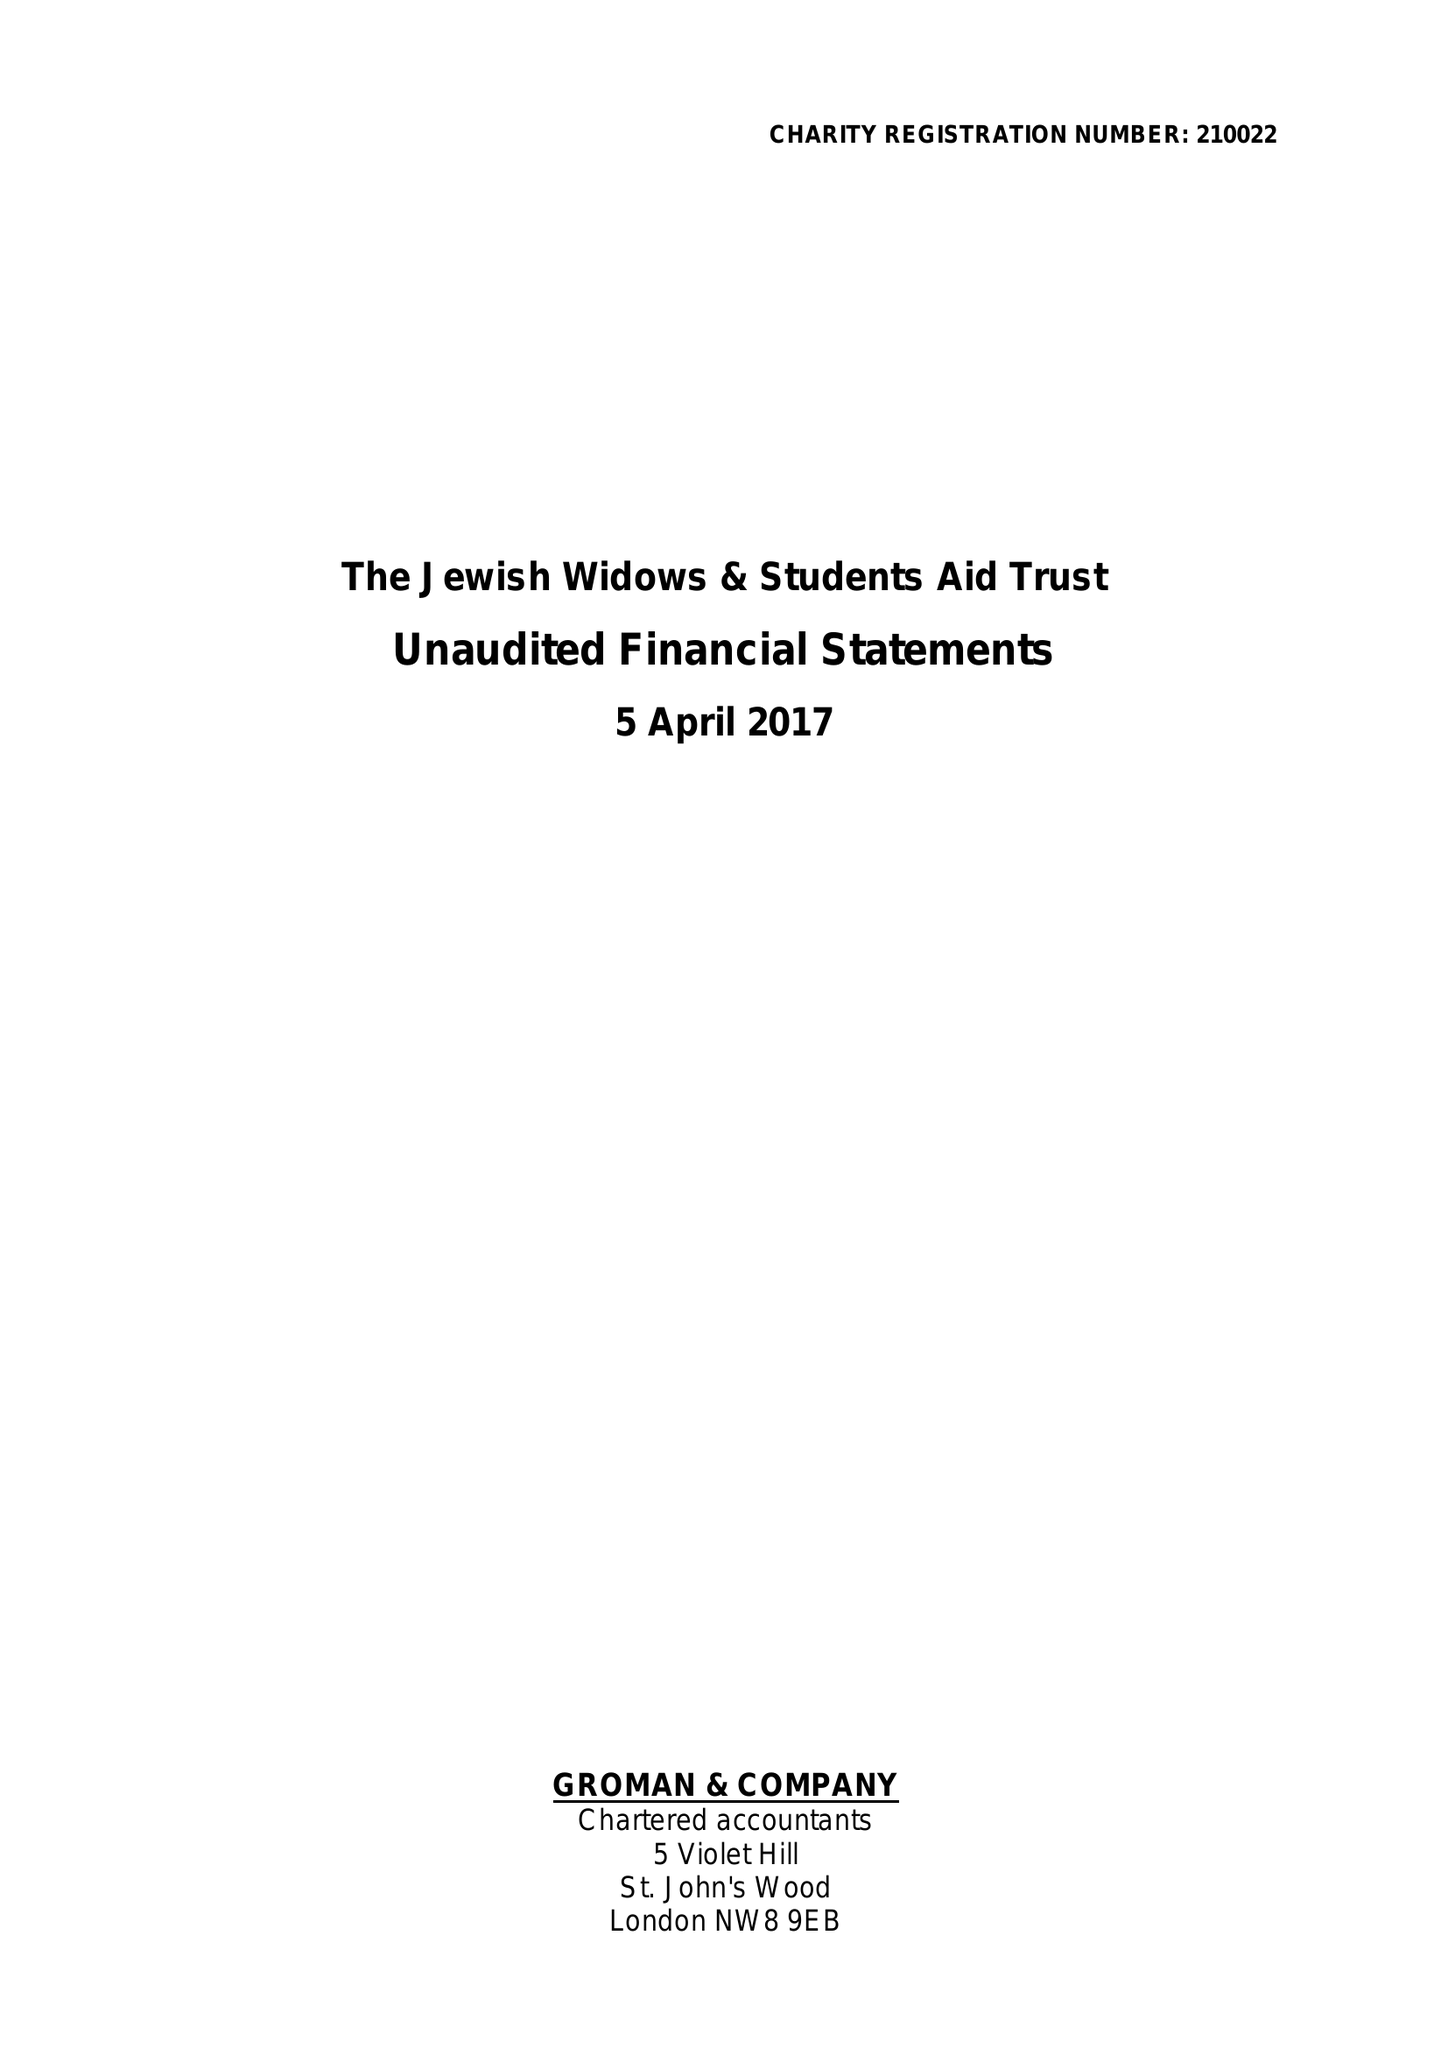What is the value for the address__post_town?
Answer the question using a single word or phrase. LONDON 